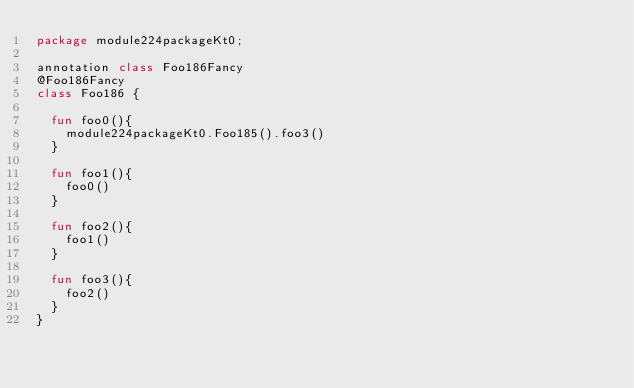Convert code to text. <code><loc_0><loc_0><loc_500><loc_500><_Kotlin_>package module224packageKt0;

annotation class Foo186Fancy
@Foo186Fancy
class Foo186 {

  fun foo0(){
    module224packageKt0.Foo185().foo3()
  }

  fun foo1(){
    foo0()
  }

  fun foo2(){
    foo1()
  }

  fun foo3(){
    foo2()
  }
}</code> 